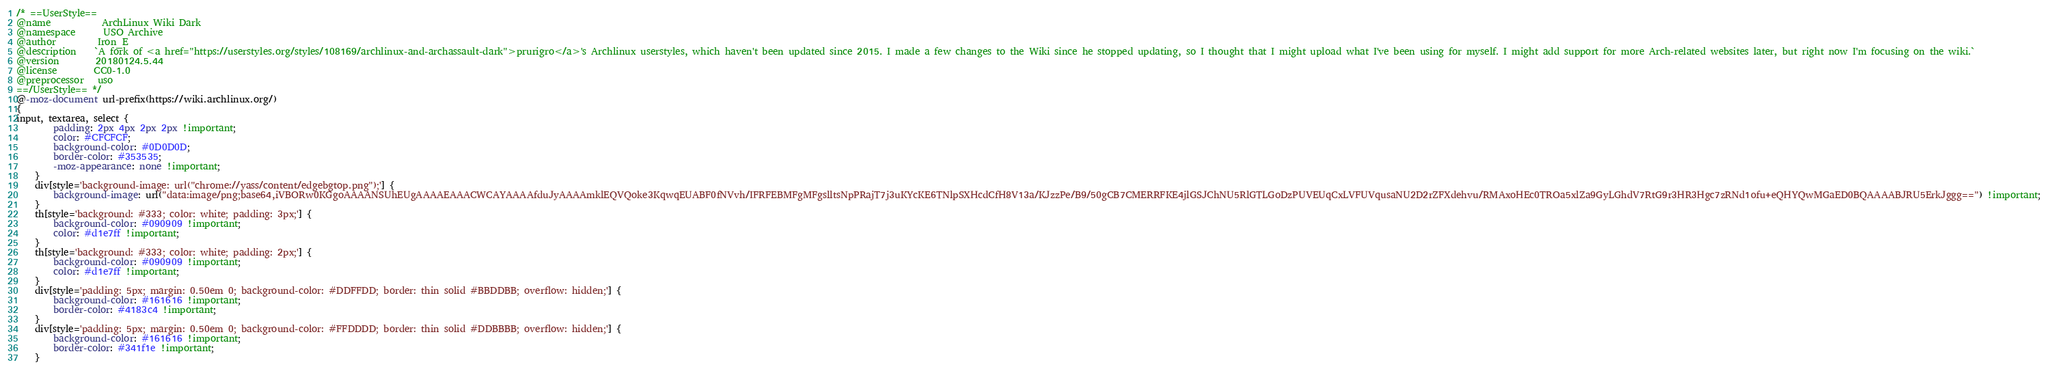Convert code to text. <code><loc_0><loc_0><loc_500><loc_500><_CSS_>/* ==UserStyle==
@name           ArchLinux Wiki Dark
@namespace      USO Archive
@author         Iron_E
@description    `A fork of <a href="https://userstyles.org/styles/108169/archlinux-and-archassault-dark">prurigro</a>'s Archlinux userstyles, which haven't been updated since 2015. I made a few changes to the Wiki since he stopped updating, so I thought that I might upload what I've been using for myself. I might add support for more Arch-related websites later, but right now I'm focusing on the wiki.`
@version        20180124.5.44
@license        CC0-1.0
@preprocessor   uso
==/UserStyle== */
@-moz-document url-prefix(https://wiki.archlinux.org/)
{
input, textarea, select {
        padding: 2px 4px 2px 2px !important;
        color: #CFCFCF;
        background-color: #0D0D0D;
        border-color: #353535;
        -moz-appearance: none !important;
    }
    div[style='background-image: url("chrome://yass/content/edgebgtop.png");'] {
        background-image: url("data:image/png;base64,iVBORw0KGgoAAAANSUhEUgAAAAEAAACWCAYAAAAfduJyAAAAmklEQVQoke3KqwqEUABF0fNVvh/IFRFEBMFgMFgslltsNpPRajT7j3uKYcKE6TNlpSXHcdCfH8V13a/KJzzPe/B9/50gCB7CMERRFKE4jlGSJChNU5RlGTLGoDzPUVEUqCxLVFUVqusaNU2D2rZFXdehvu/RMAxoHEc0TROa5xlZa9GyLGhdV7RtG9r3HR3Hgc7zRNd1ofu+eQHYQwMGaED0BQAAAABJRU5ErkJggg==") !important;
    }
    th[style='background: #333; color: white; padding: 3px;'] {
        background-color: #090909 !important;
        color: #d1e7ff !important;
    }
    th[style='background: #333; color: white; padding: 2px;'] {
        background-color: #090909 !important;
        color: #d1e7ff !important;
    }
    div[style='padding: 5px; margin: 0.50em 0; background-color: #DDFFDD; border: thin solid #BBDDBB; overflow: hidden;'] {
        background-color: #161616 !important;
        border-color: #4183c4 !important;
    }
    div[style='padding: 5px; margin: 0.50em 0; background-color: #FFDDDD; border: thin solid #DDBBBB; overflow: hidden;'] {
        background-color: #161616 !important;
        border-color: #341f1e !important;
    }</code> 